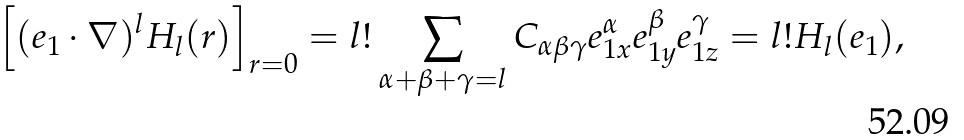<formula> <loc_0><loc_0><loc_500><loc_500>\left [ ( { e } _ { 1 } \cdot \nabla ) ^ { l } H _ { l } ( { r } ) \right ] _ { r = 0 } = l ! \sum _ { \alpha + \beta + \gamma = l } C _ { \alpha \beta \gamma } e _ { 1 x } ^ { \alpha } e _ { 1 y } ^ { \beta } e _ { 1 z } ^ { \gamma } = l ! H _ { l } ( { e } _ { 1 } ) ,</formula> 